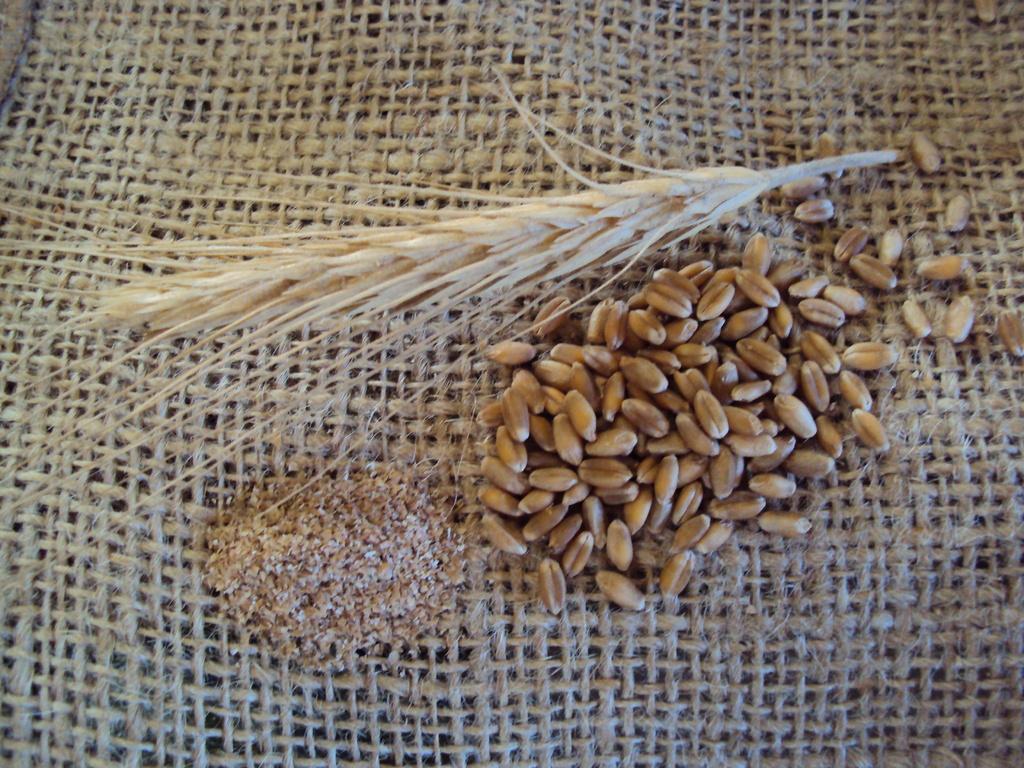How would you summarize this image in a sentence or two? In this image I can see few food items, they are in brown and cream color. The food items are on the brown color surface. 